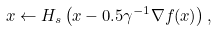<formula> <loc_0><loc_0><loc_500><loc_500>x \gets H _ { s } \left ( x - 0 . 5 \gamma ^ { - 1 } \nabla f ( x ) \right ) ,</formula> 